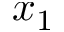<formula> <loc_0><loc_0><loc_500><loc_500>x _ { 1 }</formula> 